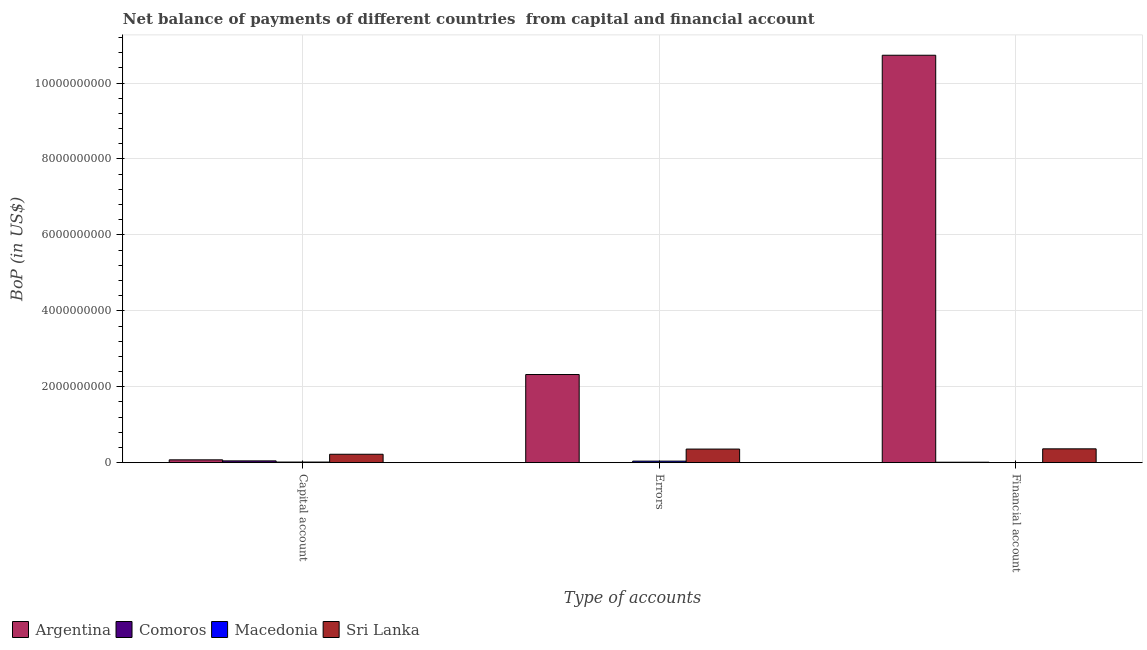How many different coloured bars are there?
Offer a terse response. 4. Are the number of bars per tick equal to the number of legend labels?
Your answer should be very brief. No. Are the number of bars on each tick of the X-axis equal?
Keep it short and to the point. No. How many bars are there on the 3rd tick from the right?
Your response must be concise. 4. What is the label of the 3rd group of bars from the left?
Your answer should be very brief. Financial account. What is the amount of errors in Sri Lanka?
Give a very brief answer. 3.58e+08. Across all countries, what is the maximum amount of financial account?
Ensure brevity in your answer.  1.07e+1. Across all countries, what is the minimum amount of financial account?
Your answer should be compact. 0. In which country was the amount of financial account maximum?
Provide a short and direct response. Argentina. What is the total amount of errors in the graph?
Provide a short and direct response. 2.72e+09. What is the difference between the amount of net capital account in Argentina and that in Macedonia?
Offer a very short reply. 5.85e+07. What is the difference between the amount of net capital account in Argentina and the amount of financial account in Sri Lanka?
Offer a very short reply. -2.90e+08. What is the average amount of errors per country?
Keep it short and to the point. 6.81e+08. What is the difference between the amount of net capital account and amount of financial account in Sri Lanka?
Your answer should be compact. -1.43e+08. In how many countries, is the amount of net capital account greater than 6000000000 US$?
Your response must be concise. 0. What is the ratio of the amount of errors in Macedonia to that in Comoros?
Provide a succinct answer. 9.9. Is the difference between the amount of financial account in Sri Lanka and Argentina greater than the difference between the amount of net capital account in Sri Lanka and Argentina?
Offer a very short reply. No. What is the difference between the highest and the second highest amount of net capital account?
Your answer should be compact. 1.47e+08. What is the difference between the highest and the lowest amount of net capital account?
Make the answer very short. 2.06e+08. Is it the case that in every country, the sum of the amount of net capital account and amount of errors is greater than the amount of financial account?
Your answer should be very brief. No. Are all the bars in the graph horizontal?
Give a very brief answer. No. How many countries are there in the graph?
Keep it short and to the point. 4. What is the title of the graph?
Offer a very short reply. Net balance of payments of different countries  from capital and financial account. What is the label or title of the X-axis?
Provide a succinct answer. Type of accounts. What is the label or title of the Y-axis?
Make the answer very short. BoP (in US$). What is the BoP (in US$) of Argentina in Capital account?
Provide a succinct answer. 7.40e+07. What is the BoP (in US$) in Comoros in Capital account?
Keep it short and to the point. 4.67e+07. What is the BoP (in US$) of Macedonia in Capital account?
Your answer should be very brief. 1.55e+07. What is the BoP (in US$) in Sri Lanka in Capital account?
Ensure brevity in your answer.  2.21e+08. What is the BoP (in US$) of Argentina in Errors?
Keep it short and to the point. 2.32e+09. What is the BoP (in US$) of Comoros in Errors?
Provide a short and direct response. 4.08e+06. What is the BoP (in US$) of Macedonia in Errors?
Keep it short and to the point. 4.04e+07. What is the BoP (in US$) in Sri Lanka in Errors?
Your answer should be very brief. 3.58e+08. What is the BoP (in US$) in Argentina in Financial account?
Your answer should be very brief. 1.07e+1. What is the BoP (in US$) in Comoros in Financial account?
Offer a terse response. 1.15e+07. What is the BoP (in US$) in Macedonia in Financial account?
Give a very brief answer. 0. What is the BoP (in US$) of Sri Lanka in Financial account?
Your answer should be very brief. 3.64e+08. Across all Type of accounts, what is the maximum BoP (in US$) of Argentina?
Provide a succinct answer. 1.07e+1. Across all Type of accounts, what is the maximum BoP (in US$) in Comoros?
Give a very brief answer. 4.67e+07. Across all Type of accounts, what is the maximum BoP (in US$) of Macedonia?
Your response must be concise. 4.04e+07. Across all Type of accounts, what is the maximum BoP (in US$) in Sri Lanka?
Your answer should be very brief. 3.64e+08. Across all Type of accounts, what is the minimum BoP (in US$) of Argentina?
Your answer should be very brief. 7.40e+07. Across all Type of accounts, what is the minimum BoP (in US$) in Comoros?
Offer a very short reply. 4.08e+06. Across all Type of accounts, what is the minimum BoP (in US$) in Sri Lanka?
Your answer should be very brief. 2.21e+08. What is the total BoP (in US$) of Argentina in the graph?
Your answer should be compact. 1.31e+1. What is the total BoP (in US$) in Comoros in the graph?
Give a very brief answer. 6.23e+07. What is the total BoP (in US$) in Macedonia in the graph?
Your answer should be compact. 5.59e+07. What is the total BoP (in US$) in Sri Lanka in the graph?
Provide a short and direct response. 9.43e+08. What is the difference between the BoP (in US$) of Argentina in Capital account and that in Errors?
Your answer should be compact. -2.25e+09. What is the difference between the BoP (in US$) in Comoros in Capital account and that in Errors?
Offer a very short reply. 4.26e+07. What is the difference between the BoP (in US$) in Macedonia in Capital account and that in Errors?
Offer a very short reply. -2.49e+07. What is the difference between the BoP (in US$) in Sri Lanka in Capital account and that in Errors?
Give a very brief answer. -1.36e+08. What is the difference between the BoP (in US$) in Argentina in Capital account and that in Financial account?
Your answer should be compact. -1.07e+1. What is the difference between the BoP (in US$) of Comoros in Capital account and that in Financial account?
Keep it short and to the point. 3.51e+07. What is the difference between the BoP (in US$) in Sri Lanka in Capital account and that in Financial account?
Provide a short and direct response. -1.43e+08. What is the difference between the BoP (in US$) of Argentina in Errors and that in Financial account?
Your answer should be very brief. -8.41e+09. What is the difference between the BoP (in US$) in Comoros in Errors and that in Financial account?
Provide a short and direct response. -7.45e+06. What is the difference between the BoP (in US$) of Sri Lanka in Errors and that in Financial account?
Offer a terse response. -6.50e+06. What is the difference between the BoP (in US$) of Argentina in Capital account and the BoP (in US$) of Comoros in Errors?
Your response must be concise. 6.99e+07. What is the difference between the BoP (in US$) in Argentina in Capital account and the BoP (in US$) in Macedonia in Errors?
Ensure brevity in your answer.  3.36e+07. What is the difference between the BoP (in US$) in Argentina in Capital account and the BoP (in US$) in Sri Lanka in Errors?
Provide a succinct answer. -2.84e+08. What is the difference between the BoP (in US$) of Comoros in Capital account and the BoP (in US$) of Macedonia in Errors?
Make the answer very short. 6.29e+06. What is the difference between the BoP (in US$) in Comoros in Capital account and the BoP (in US$) in Sri Lanka in Errors?
Keep it short and to the point. -3.11e+08. What is the difference between the BoP (in US$) of Macedonia in Capital account and the BoP (in US$) of Sri Lanka in Errors?
Your response must be concise. -3.42e+08. What is the difference between the BoP (in US$) of Argentina in Capital account and the BoP (in US$) of Comoros in Financial account?
Ensure brevity in your answer.  6.25e+07. What is the difference between the BoP (in US$) in Argentina in Capital account and the BoP (in US$) in Sri Lanka in Financial account?
Offer a very short reply. -2.90e+08. What is the difference between the BoP (in US$) in Comoros in Capital account and the BoP (in US$) in Sri Lanka in Financial account?
Ensure brevity in your answer.  -3.17e+08. What is the difference between the BoP (in US$) in Macedonia in Capital account and the BoP (in US$) in Sri Lanka in Financial account?
Your answer should be compact. -3.49e+08. What is the difference between the BoP (in US$) in Argentina in Errors and the BoP (in US$) in Comoros in Financial account?
Ensure brevity in your answer.  2.31e+09. What is the difference between the BoP (in US$) in Argentina in Errors and the BoP (in US$) in Sri Lanka in Financial account?
Your answer should be compact. 1.96e+09. What is the difference between the BoP (in US$) in Comoros in Errors and the BoP (in US$) in Sri Lanka in Financial account?
Provide a short and direct response. -3.60e+08. What is the difference between the BoP (in US$) in Macedonia in Errors and the BoP (in US$) in Sri Lanka in Financial account?
Your response must be concise. -3.24e+08. What is the average BoP (in US$) of Argentina per Type of accounts?
Keep it short and to the point. 4.38e+09. What is the average BoP (in US$) in Comoros per Type of accounts?
Your answer should be compact. 2.08e+07. What is the average BoP (in US$) of Macedonia per Type of accounts?
Offer a very short reply. 1.86e+07. What is the average BoP (in US$) in Sri Lanka per Type of accounts?
Make the answer very short. 3.14e+08. What is the difference between the BoP (in US$) in Argentina and BoP (in US$) in Comoros in Capital account?
Ensure brevity in your answer.  2.73e+07. What is the difference between the BoP (in US$) of Argentina and BoP (in US$) of Macedonia in Capital account?
Ensure brevity in your answer.  5.85e+07. What is the difference between the BoP (in US$) of Argentina and BoP (in US$) of Sri Lanka in Capital account?
Your answer should be very brief. -1.47e+08. What is the difference between the BoP (in US$) of Comoros and BoP (in US$) of Macedonia in Capital account?
Make the answer very short. 3.12e+07. What is the difference between the BoP (in US$) in Comoros and BoP (in US$) in Sri Lanka in Capital account?
Your answer should be compact. -1.75e+08. What is the difference between the BoP (in US$) of Macedonia and BoP (in US$) of Sri Lanka in Capital account?
Provide a short and direct response. -2.06e+08. What is the difference between the BoP (in US$) of Argentina and BoP (in US$) of Comoros in Errors?
Ensure brevity in your answer.  2.32e+09. What is the difference between the BoP (in US$) of Argentina and BoP (in US$) of Macedonia in Errors?
Keep it short and to the point. 2.28e+09. What is the difference between the BoP (in US$) in Argentina and BoP (in US$) in Sri Lanka in Errors?
Offer a terse response. 1.96e+09. What is the difference between the BoP (in US$) in Comoros and BoP (in US$) in Macedonia in Errors?
Keep it short and to the point. -3.63e+07. What is the difference between the BoP (in US$) of Comoros and BoP (in US$) of Sri Lanka in Errors?
Your answer should be compact. -3.53e+08. What is the difference between the BoP (in US$) of Macedonia and BoP (in US$) of Sri Lanka in Errors?
Your answer should be very brief. -3.17e+08. What is the difference between the BoP (in US$) in Argentina and BoP (in US$) in Comoros in Financial account?
Offer a very short reply. 1.07e+1. What is the difference between the BoP (in US$) of Argentina and BoP (in US$) of Sri Lanka in Financial account?
Offer a terse response. 1.04e+1. What is the difference between the BoP (in US$) of Comoros and BoP (in US$) of Sri Lanka in Financial account?
Your answer should be compact. -3.53e+08. What is the ratio of the BoP (in US$) in Argentina in Capital account to that in Errors?
Give a very brief answer. 0.03. What is the ratio of the BoP (in US$) of Comoros in Capital account to that in Errors?
Offer a terse response. 11.45. What is the ratio of the BoP (in US$) of Macedonia in Capital account to that in Errors?
Provide a succinct answer. 0.38. What is the ratio of the BoP (in US$) of Sri Lanka in Capital account to that in Errors?
Ensure brevity in your answer.  0.62. What is the ratio of the BoP (in US$) of Argentina in Capital account to that in Financial account?
Make the answer very short. 0.01. What is the ratio of the BoP (in US$) of Comoros in Capital account to that in Financial account?
Offer a terse response. 4.05. What is the ratio of the BoP (in US$) of Sri Lanka in Capital account to that in Financial account?
Your response must be concise. 0.61. What is the ratio of the BoP (in US$) of Argentina in Errors to that in Financial account?
Your answer should be compact. 0.22. What is the ratio of the BoP (in US$) in Comoros in Errors to that in Financial account?
Your answer should be compact. 0.35. What is the ratio of the BoP (in US$) in Sri Lanka in Errors to that in Financial account?
Keep it short and to the point. 0.98. What is the difference between the highest and the second highest BoP (in US$) of Argentina?
Make the answer very short. 8.41e+09. What is the difference between the highest and the second highest BoP (in US$) of Comoros?
Ensure brevity in your answer.  3.51e+07. What is the difference between the highest and the second highest BoP (in US$) of Sri Lanka?
Provide a succinct answer. 6.50e+06. What is the difference between the highest and the lowest BoP (in US$) in Argentina?
Offer a very short reply. 1.07e+1. What is the difference between the highest and the lowest BoP (in US$) of Comoros?
Offer a terse response. 4.26e+07. What is the difference between the highest and the lowest BoP (in US$) in Macedonia?
Your answer should be very brief. 4.04e+07. What is the difference between the highest and the lowest BoP (in US$) in Sri Lanka?
Offer a terse response. 1.43e+08. 